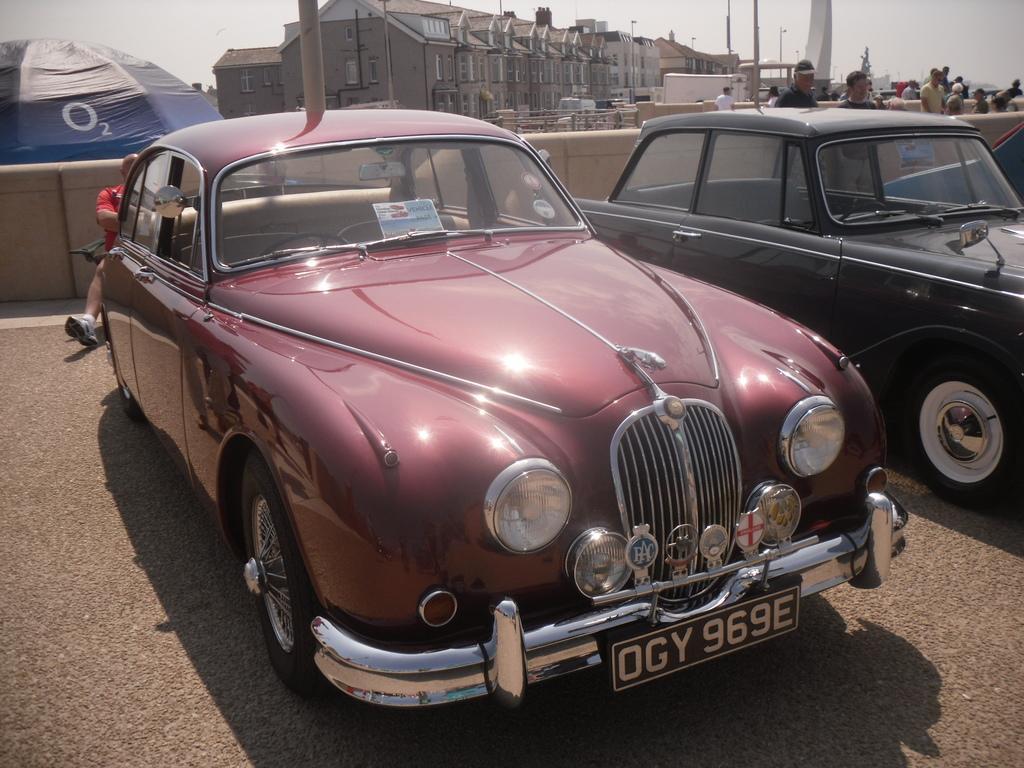How would you summarize this image in a sentence or two? In this picture we can see there are vehicles and people. Behind the people, there are buildings, poles and the sky. At the top left corner of the image, there is an object and wall. 